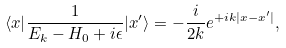Convert formula to latex. <formula><loc_0><loc_0><loc_500><loc_500>\langle x | \frac { 1 } { E _ { k } - H _ { 0 } + i \epsilon } | x ^ { \prime } \rangle = - \frac { i } { 2 k } e ^ { + i k | x - x ^ { \prime } | } ,</formula> 